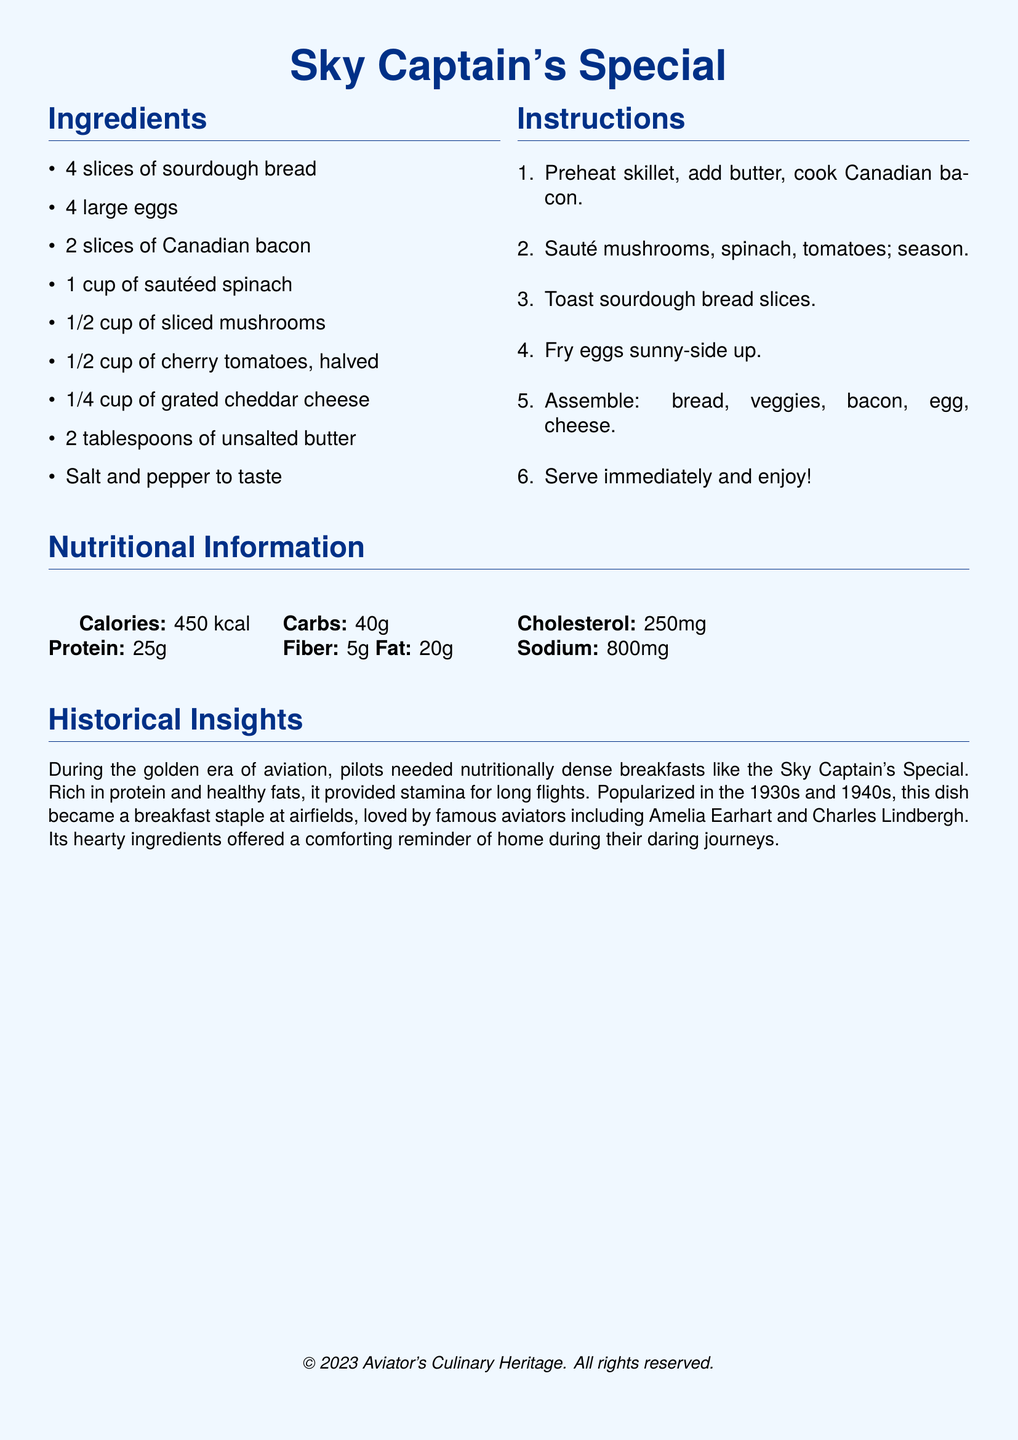What are the main ingredients of the recipe? The main ingredients are listed in the ingredients section of the document, which includes sourdough bread, eggs, Canadian bacon, etc.
Answer: Sourdough bread, eggs, Canadian bacon, sautéed spinach, mushrooms, cherry tomatoes, cheddar cheese, unsalted butter, salt, pepper How many slices of bread are needed? The quantity of sourdough bread is specified in the ingredients list.
Answer: 4 slices What is the total calorie count for the dish? The total calories is stated in the nutritional information section.
Answer: 450 kcal Who is mentioned as a famous aviator who loved this dish? The historical insights section mentions aviators who enjoyed the meal.
Answer: Amelia Earhart What is the preparation method for the eggs? The instructions indicate the cooking method for the eggs.
Answer: Fry sunny-side up How many grams of protein are in the recipe? The protein content is provided in the nutritional information section.
Answer: 25g What year was the dish popularized? The historical insights section references the time frame when the dish gained popularity.
Answer: 1930s and 1940s What type of bread is used in this recipe? The specific type of bread is listed in the ingredients section.
Answer: Sourdough What type of cheese is included in the recipe? The ingredients list specifies the type of cheese used in the dish.
Answer: Cheddar cheese 